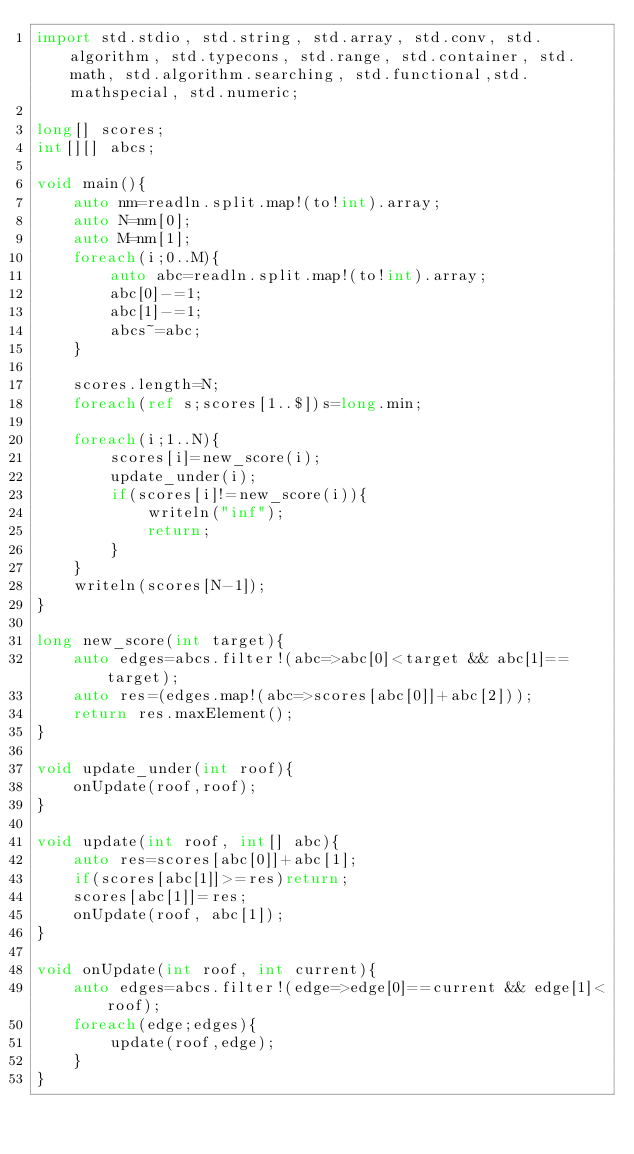<code> <loc_0><loc_0><loc_500><loc_500><_D_>import std.stdio, std.string, std.array, std.conv, std.algorithm, std.typecons, std.range, std.container, std.math, std.algorithm.searching, std.functional,std.mathspecial, std.numeric;

long[] scores;
int[][] abcs;
 
void main(){
    auto nm=readln.split.map!(to!int).array;
    auto N=nm[0];
    auto M=nm[1];
    foreach(i;0..M){
        auto abc=readln.split.map!(to!int).array;
        abc[0]-=1;
        abc[1]-=1;
        abcs~=abc;
    }

    scores.length=N;
    foreach(ref s;scores[1..$])s=long.min;
 
    foreach(i;1..N){
        scores[i]=new_score(i);
        update_under(i);
        if(scores[i]!=new_score(i)){
            writeln("inf");
            return;
        }
    }
    writeln(scores[N-1]);
}

long new_score(int target){
    auto edges=abcs.filter!(abc=>abc[0]<target && abc[1]==target);
    auto res=(edges.map!(abc=>scores[abc[0]]+abc[2]));
    return res.maxElement();
}

void update_under(int roof){
    onUpdate(roof,roof);
}

void update(int roof, int[] abc){
    auto res=scores[abc[0]]+abc[1];
    if(scores[abc[1]]>=res)return;
    scores[abc[1]]=res;
    onUpdate(roof, abc[1]);
}

void onUpdate(int roof, int current){
    auto edges=abcs.filter!(edge=>edge[0]==current && edge[1]<roof);
    foreach(edge;edges){
        update(roof,edge);
    }
}
</code> 